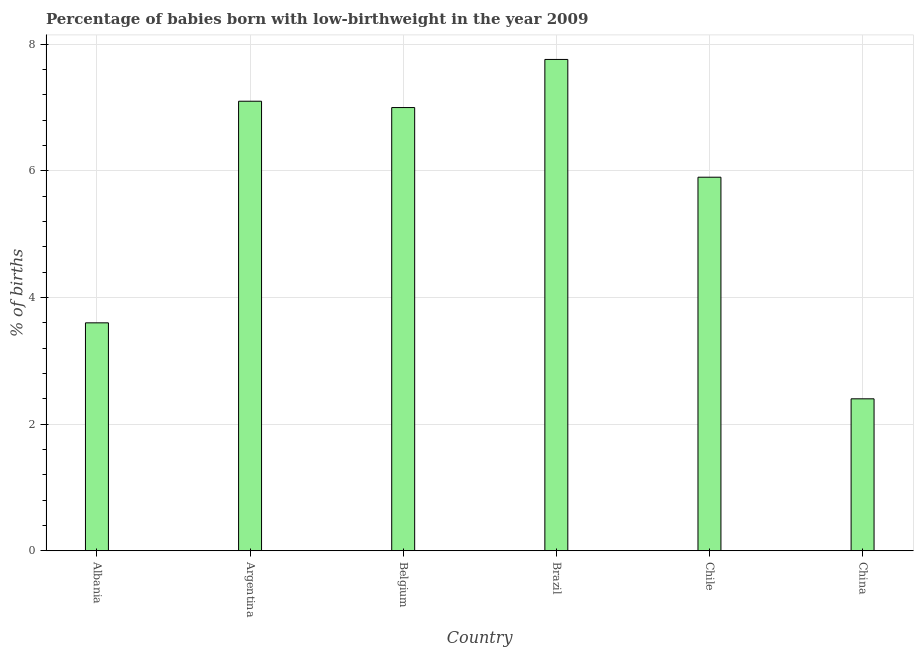Does the graph contain any zero values?
Give a very brief answer. No. Does the graph contain grids?
Give a very brief answer. Yes. What is the title of the graph?
Your response must be concise. Percentage of babies born with low-birthweight in the year 2009. What is the label or title of the X-axis?
Your response must be concise. Country. What is the label or title of the Y-axis?
Give a very brief answer. % of births. What is the percentage of babies who were born with low-birthweight in Argentina?
Keep it short and to the point. 7.1. Across all countries, what is the maximum percentage of babies who were born with low-birthweight?
Make the answer very short. 7.76. What is the sum of the percentage of babies who were born with low-birthweight?
Make the answer very short. 33.76. What is the difference between the percentage of babies who were born with low-birthweight in Belgium and China?
Your answer should be very brief. 4.6. What is the average percentage of babies who were born with low-birthweight per country?
Make the answer very short. 5.63. What is the median percentage of babies who were born with low-birthweight?
Offer a very short reply. 6.45. In how many countries, is the percentage of babies who were born with low-birthweight greater than 3.2 %?
Offer a very short reply. 5. What is the ratio of the percentage of babies who were born with low-birthweight in Albania to that in Argentina?
Offer a very short reply. 0.51. Is the difference between the percentage of babies who were born with low-birthweight in Argentina and Brazil greater than the difference between any two countries?
Your answer should be very brief. No. What is the difference between the highest and the second highest percentage of babies who were born with low-birthweight?
Give a very brief answer. 0.66. What is the difference between the highest and the lowest percentage of babies who were born with low-birthweight?
Make the answer very short. 5.36. In how many countries, is the percentage of babies who were born with low-birthweight greater than the average percentage of babies who were born with low-birthweight taken over all countries?
Make the answer very short. 4. Are all the bars in the graph horizontal?
Your response must be concise. No. How many countries are there in the graph?
Make the answer very short. 6. Are the values on the major ticks of Y-axis written in scientific E-notation?
Your answer should be compact. No. What is the % of births of Brazil?
Provide a short and direct response. 7.76. What is the % of births of China?
Keep it short and to the point. 2.4. What is the difference between the % of births in Albania and Belgium?
Offer a terse response. -3.4. What is the difference between the % of births in Albania and Brazil?
Your answer should be compact. -4.16. What is the difference between the % of births in Albania and China?
Ensure brevity in your answer.  1.2. What is the difference between the % of births in Argentina and Brazil?
Make the answer very short. -0.66. What is the difference between the % of births in Argentina and Chile?
Your response must be concise. 1.2. What is the difference between the % of births in Belgium and Brazil?
Offer a terse response. -0.76. What is the difference between the % of births in Brazil and Chile?
Your answer should be compact. 1.86. What is the difference between the % of births in Brazil and China?
Provide a short and direct response. 5.36. What is the ratio of the % of births in Albania to that in Argentina?
Ensure brevity in your answer.  0.51. What is the ratio of the % of births in Albania to that in Belgium?
Your answer should be very brief. 0.51. What is the ratio of the % of births in Albania to that in Brazil?
Make the answer very short. 0.46. What is the ratio of the % of births in Albania to that in Chile?
Offer a very short reply. 0.61. What is the ratio of the % of births in Albania to that in China?
Make the answer very short. 1.5. What is the ratio of the % of births in Argentina to that in Brazil?
Offer a terse response. 0.92. What is the ratio of the % of births in Argentina to that in Chile?
Provide a short and direct response. 1.2. What is the ratio of the % of births in Argentina to that in China?
Provide a short and direct response. 2.96. What is the ratio of the % of births in Belgium to that in Brazil?
Ensure brevity in your answer.  0.9. What is the ratio of the % of births in Belgium to that in Chile?
Provide a short and direct response. 1.19. What is the ratio of the % of births in Belgium to that in China?
Offer a very short reply. 2.92. What is the ratio of the % of births in Brazil to that in Chile?
Your answer should be very brief. 1.31. What is the ratio of the % of births in Brazil to that in China?
Your response must be concise. 3.23. What is the ratio of the % of births in Chile to that in China?
Your response must be concise. 2.46. 